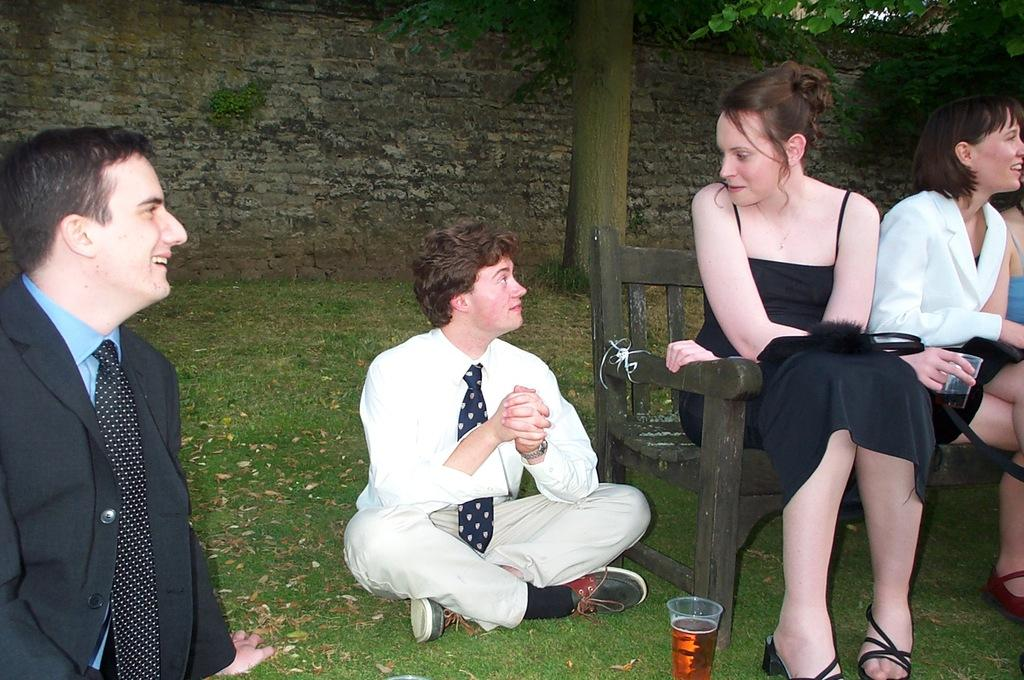What are the people in the image doing? The people in the image are sitting on the ground and on a bench. What are the people on the bench holding? The people on the bench are holding glasses. What can be seen in the background of the image? There are trees and a wall in the background of the image. What type of grain is being harvested in the alley behind the people? There is no alley or grain present in the image. 